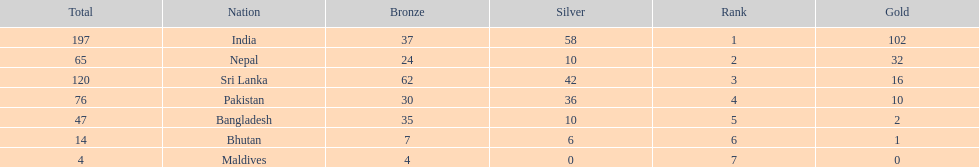How many gold medals were awarded between all 7 nations? 163. 